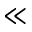<formula> <loc_0><loc_0><loc_500><loc_500>\ll</formula> 